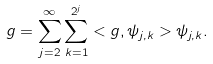<formula> <loc_0><loc_0><loc_500><loc_500>g = \sum _ { j = 2 } ^ { \infty } \sum _ { k = 1 } ^ { 2 ^ { j } } < g , \psi _ { j , k } > \psi _ { j , k } .</formula> 